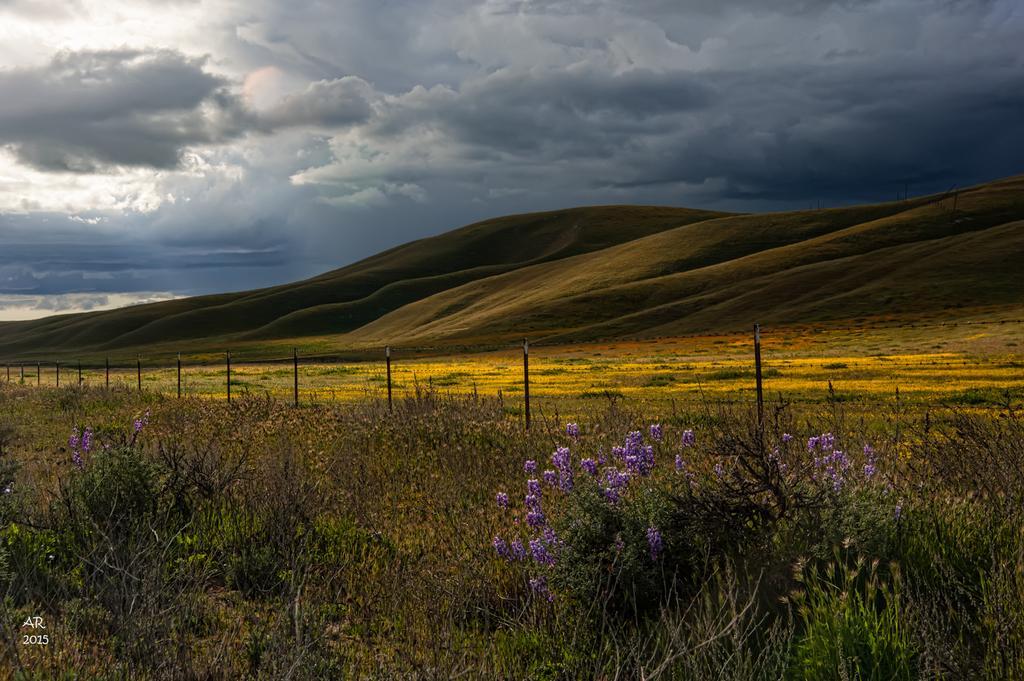Please provide a concise description of this image. In this image we can see the outside view, there are some flowers on the plants, bushes, mountains, and also we can see clouded sky. 